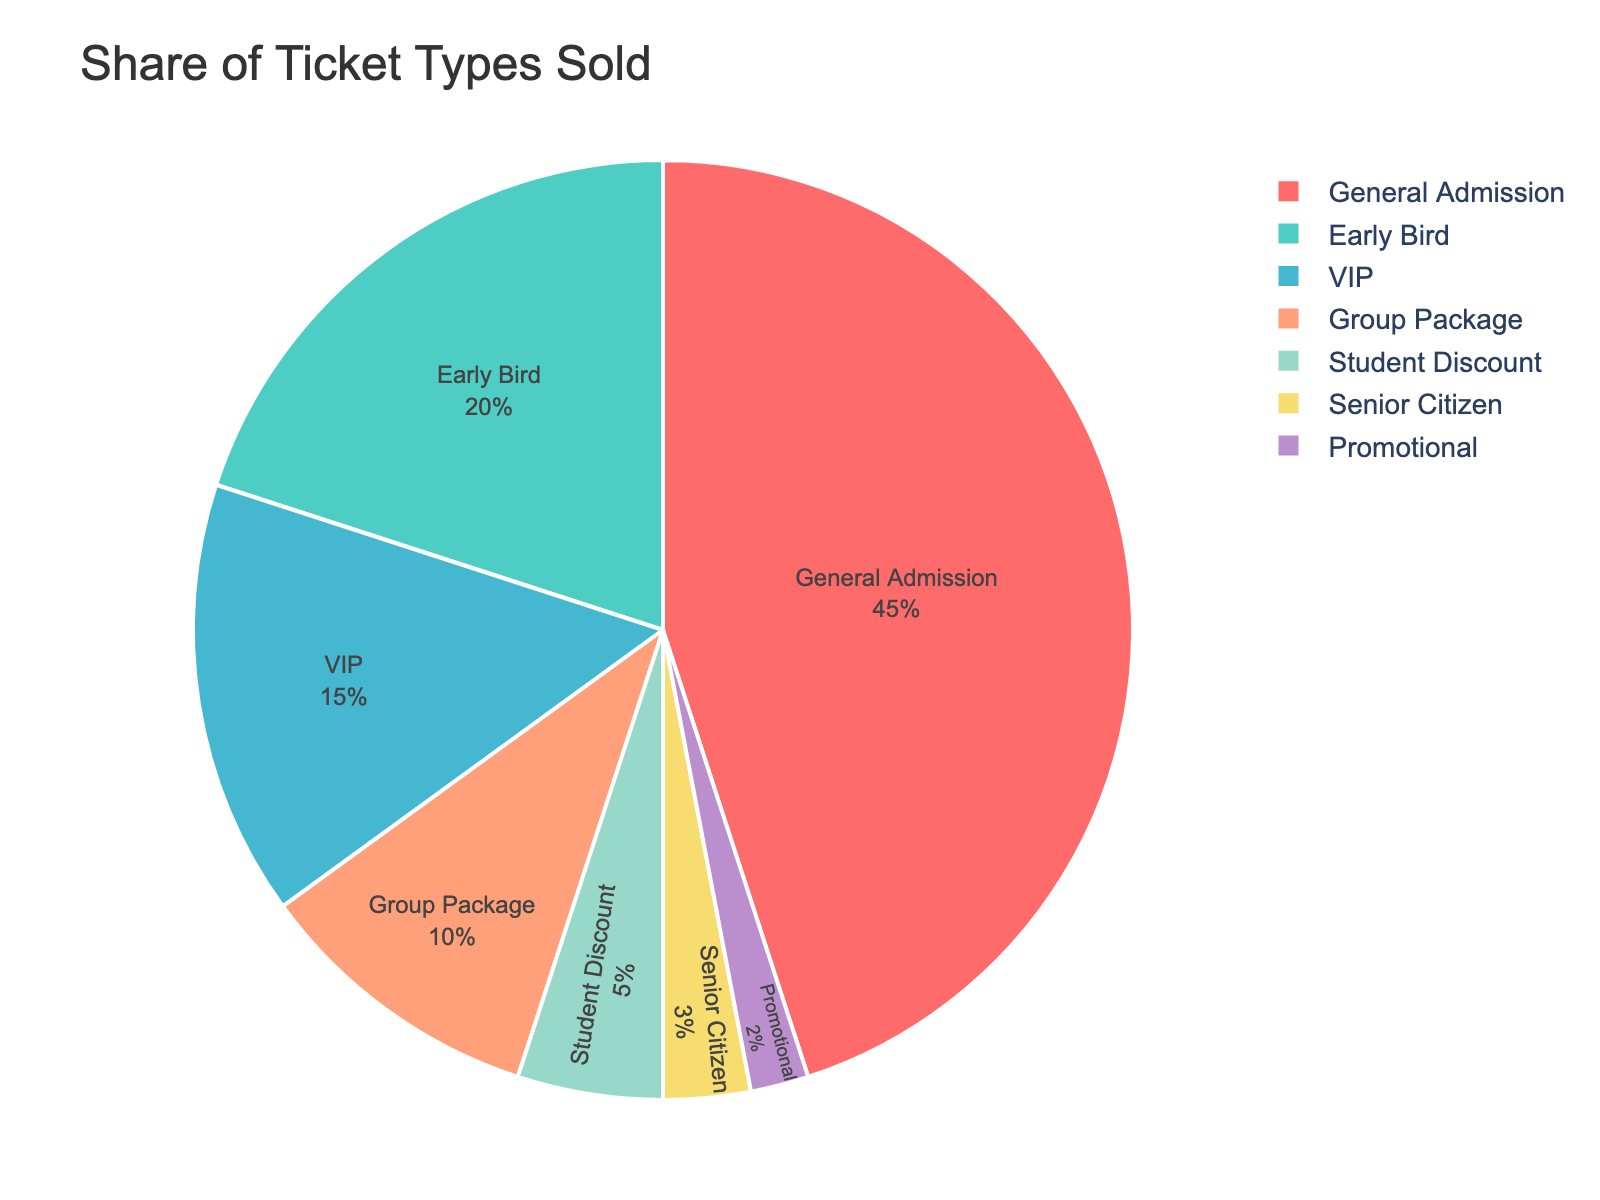What is the ticket type with the largest share of sales? The pie chart shows different ticket types and their corresponding percentages. The sector labeled "General Admission" takes up the largest portion of the chart.
Answer: General Admission What is the combined percentage of Group Package and Student Discount tickets? From the pie chart, the percentage for Group Package tickets is 10% and for Student Discount tickets is 5%. Adding these together, 10% + 5% = 15%.
Answer: 15% Which ticket types have a smaller share than Early Bird tickets? The percentage for Early Bird tickets is 20%. The ticket types with smaller shares are VIP (15%), Group Package (10%), Student Discount (5%), Senior Citizen (3%), and Promotional (2%).
Answer: VIP, Group Package, Student Discount, Senior Citizen, Promotional How much larger is the share of General Admission tickets compared to VIP tickets? General Admission has a share of 45% and VIP has 15%. The difference is calculated as 45% - 15% = 30%.
Answer: 30% Which ticket type is represented by the blue segment in the pie chart? Referring to the color scheme in the pie chart, the blue segment corresponds to the "Early Bird" ticket type.
Answer: Early Bird What is the difference in percentages between the smallest and the largest ticket type shares? The smallest share is Promotional at 2%, and the largest is General Admission at 45%. The difference is 45% - 2% = 43%.
Answer: 43% If Early Bird and VIP tickets were combined into a single category called "Premium Tickets", what would be the new percentage for this category? Early Bird tickets have 20% and VIP tickets have 15%. Combined, 20% + 15% = 35%.
Answer: 35% How do the percentages of General Admission and Group Package tickets compare? General Admission tickets have a percentage of 45%, while Group Package tickets have 10%. General Admission tickets have a higher percentage by 45% - 10% = 35%.
Answer: General Admission has 35% more What ticket type represents the smallest share on the pie chart, and what's its percentage? The smallest share is given to the "Promotional" ticket type, with a percentage of 2%.
Answer: Promotional, 2% Is the combined percentage of Student Discount and Senior Citizen tickets greater than that of Early Bird tickets? Student Discount is 5% and Senior Citizen is 3%, adding up to 5% + 3% = 8%. Early Bird is 20%. 8% is not greater than 20%.
Answer: No 